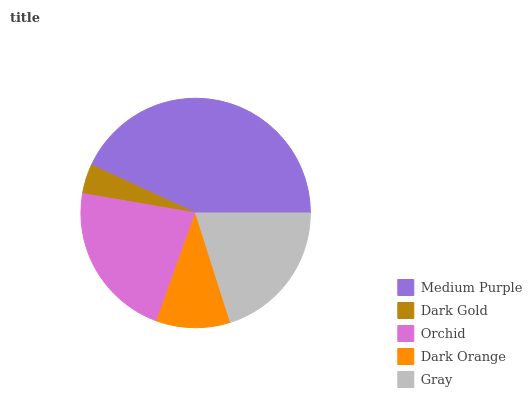Is Dark Gold the minimum?
Answer yes or no. Yes. Is Medium Purple the maximum?
Answer yes or no. Yes. Is Orchid the minimum?
Answer yes or no. No. Is Orchid the maximum?
Answer yes or no. No. Is Orchid greater than Dark Gold?
Answer yes or no. Yes. Is Dark Gold less than Orchid?
Answer yes or no. Yes. Is Dark Gold greater than Orchid?
Answer yes or no. No. Is Orchid less than Dark Gold?
Answer yes or no. No. Is Gray the high median?
Answer yes or no. Yes. Is Gray the low median?
Answer yes or no. Yes. Is Dark Gold the high median?
Answer yes or no. No. Is Dark Orange the low median?
Answer yes or no. No. 